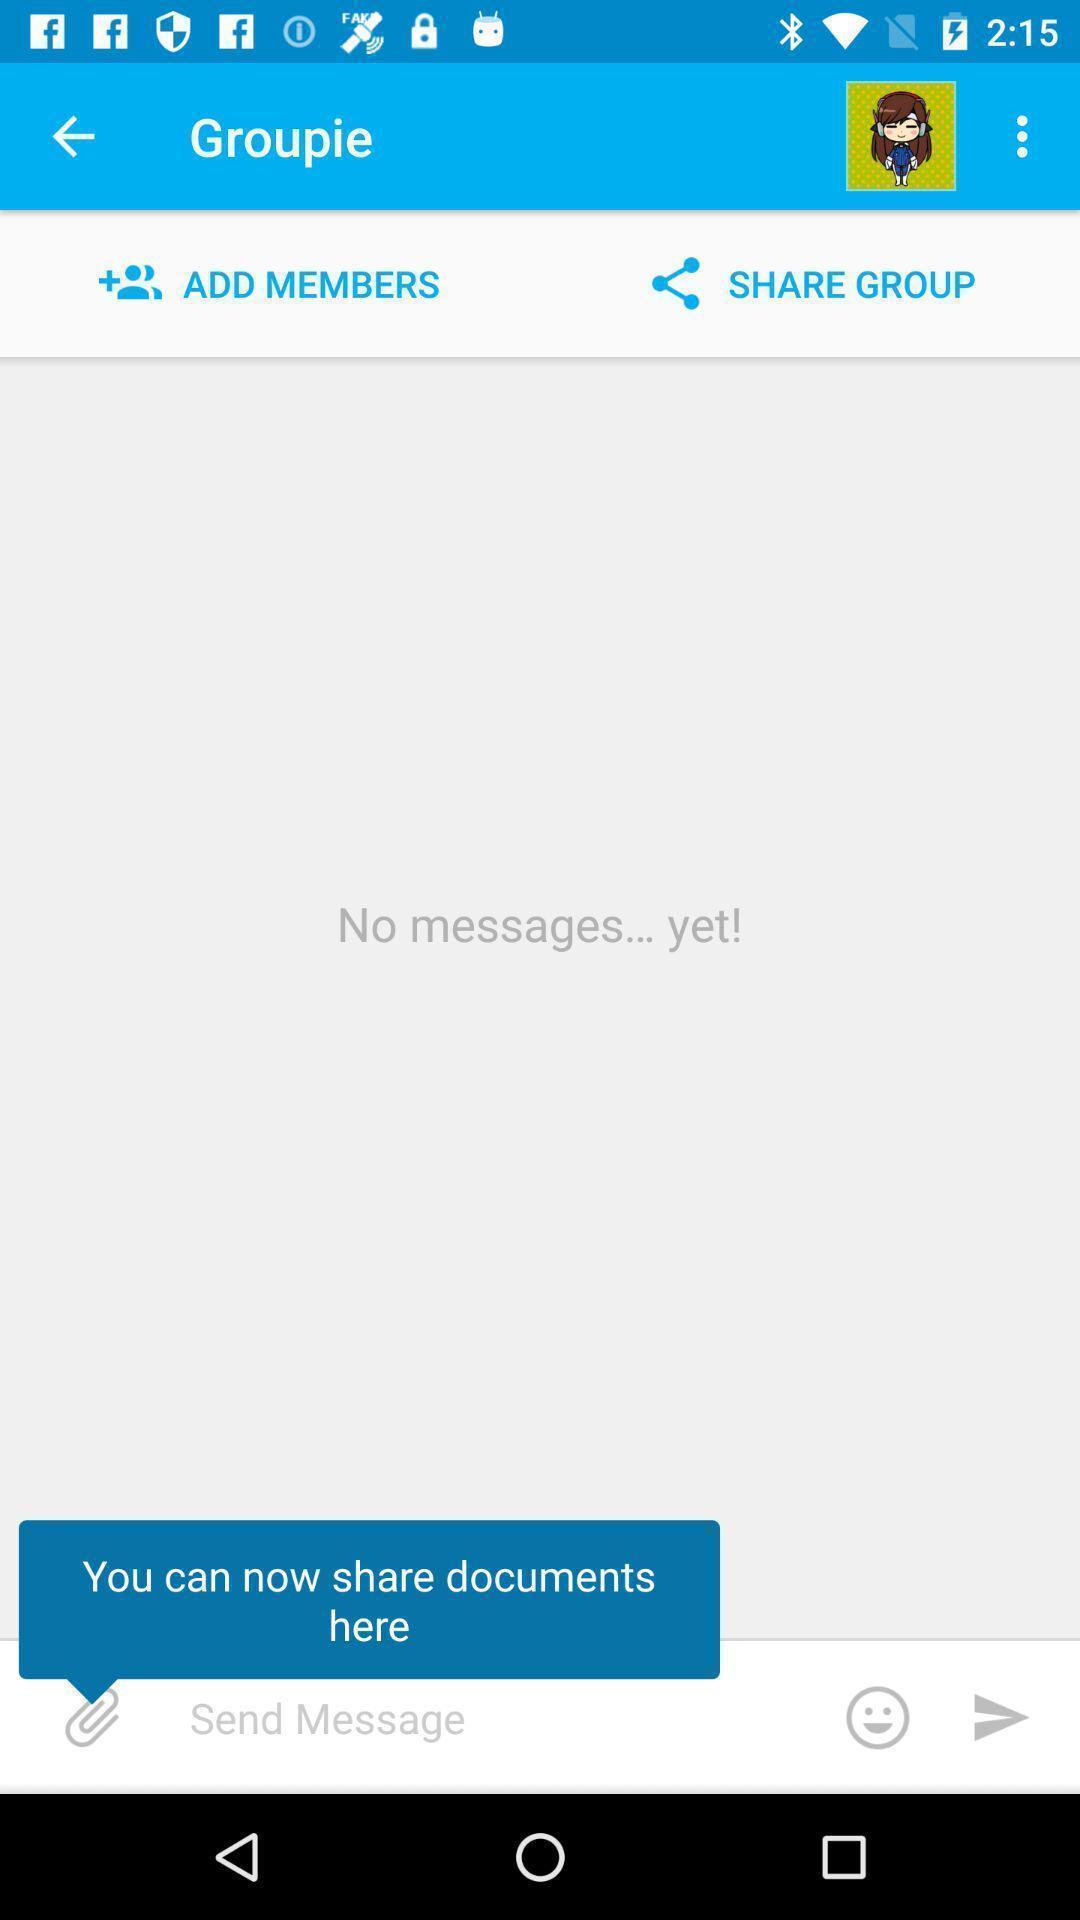Provide a description of this screenshot. Page shows the social application. 